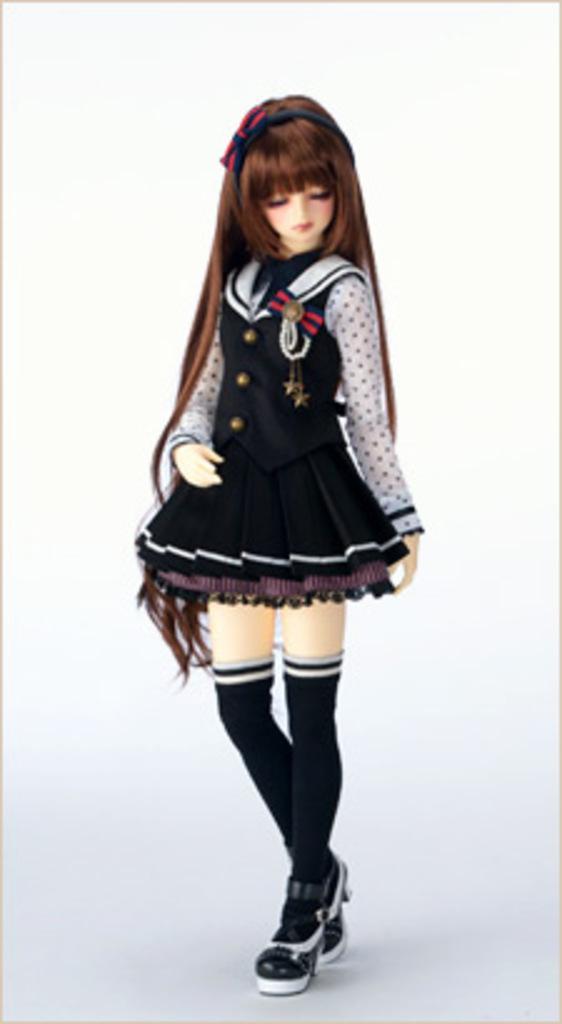Can you describe this image briefly? In this image I can see a baby doll standing with long hair and a frock. 